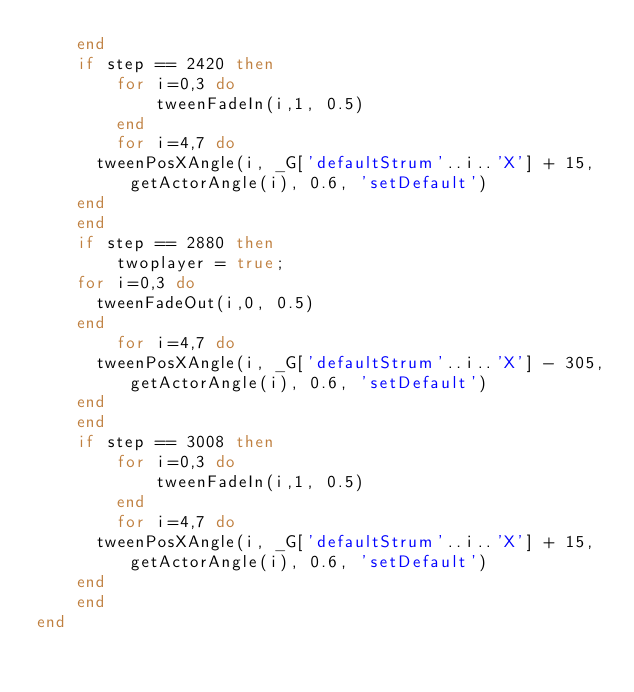Convert code to text. <code><loc_0><loc_0><loc_500><loc_500><_Lua_>    end
    if step == 2420 then 
        for i=0,3 do
            tweenFadeIn(i,1, 0.5)
        end
        for i=4,7 do
			tweenPosXAngle(i, _G['defaultStrum'..i..'X'] + 15,getActorAngle(i), 0.6, 'setDefault')
		end
    end
    if step == 2880 then
        twoplayer = true;
		for i=0,3 do
			tweenFadeOut(i,0, 0.5)
		end
        for i=4,7 do
			tweenPosXAngle(i, _G['defaultStrum'..i..'X'] - 305,getActorAngle(i), 0.6, 'setDefault')
		end
    end
    if step == 3008 then 
        for i=0,3 do
            tweenFadeIn(i,1, 0.5)
        end
        for i=4,7 do
			tweenPosXAngle(i, _G['defaultStrum'..i..'X'] + 15,getActorAngle(i), 0.6, 'setDefault')
		end
    end
end
</code> 